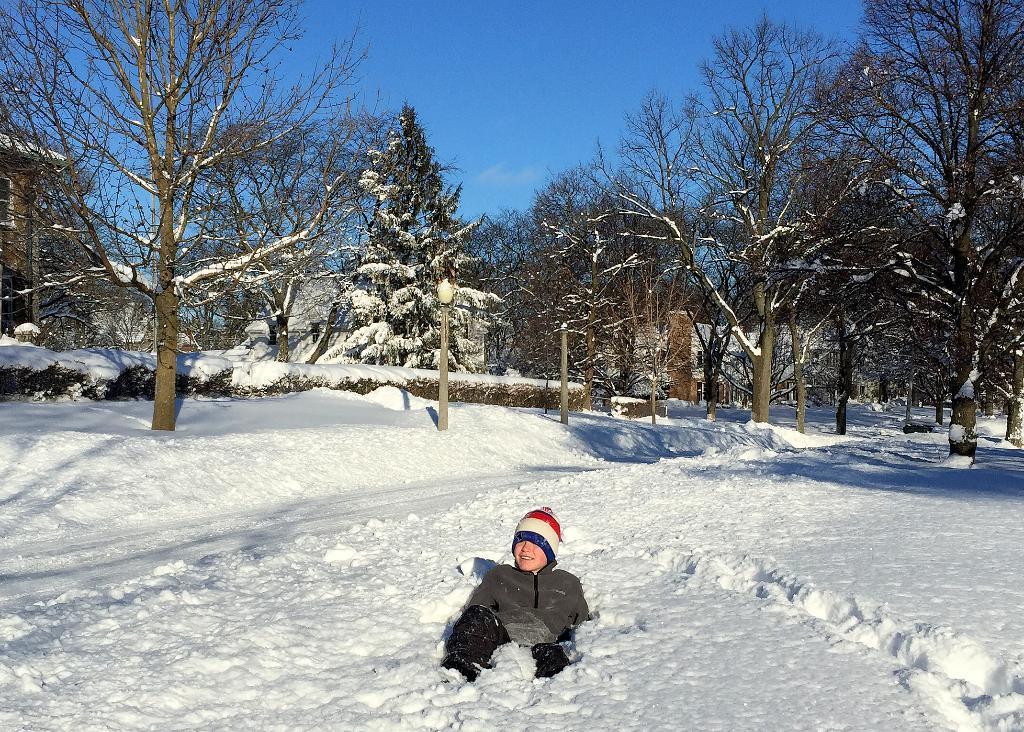Could you give a brief overview of what you see in this image? This image consists of a person lying in the snow. At the bottom, there is snow. In the background, there are many trees. At the top, there is sky. And the person is wearing a jacket along with a cap. 